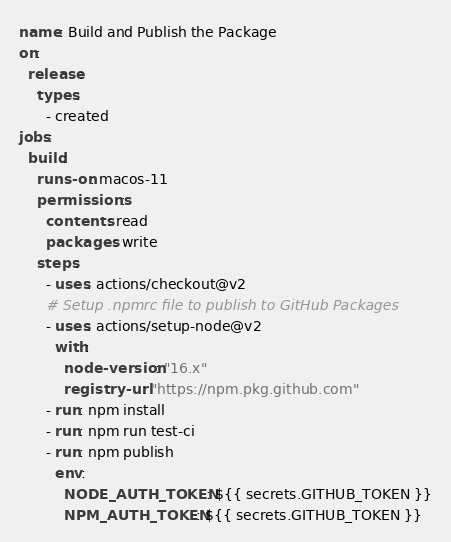<code> <loc_0><loc_0><loc_500><loc_500><_YAML_>name: Build and Publish the Package
on:
  release:
    types:
      - created
jobs:
  build:
    runs-on: macos-11
    permissions:
      contents: read
      packages: write
    steps:
      - uses: actions/checkout@v2
      # Setup .npmrc file to publish to GitHub Packages
      - uses: actions/setup-node@v2
        with:
          node-version: "16.x"
          registry-url: "https://npm.pkg.github.com"
      - run: npm install
      - run: npm run test-ci
      - run: npm publish
        env:
          NODE_AUTH_TOKEN: ${{ secrets.GITHUB_TOKEN }}
          NPM_AUTH_TOKEN: ${{ secrets.GITHUB_TOKEN }}
</code> 